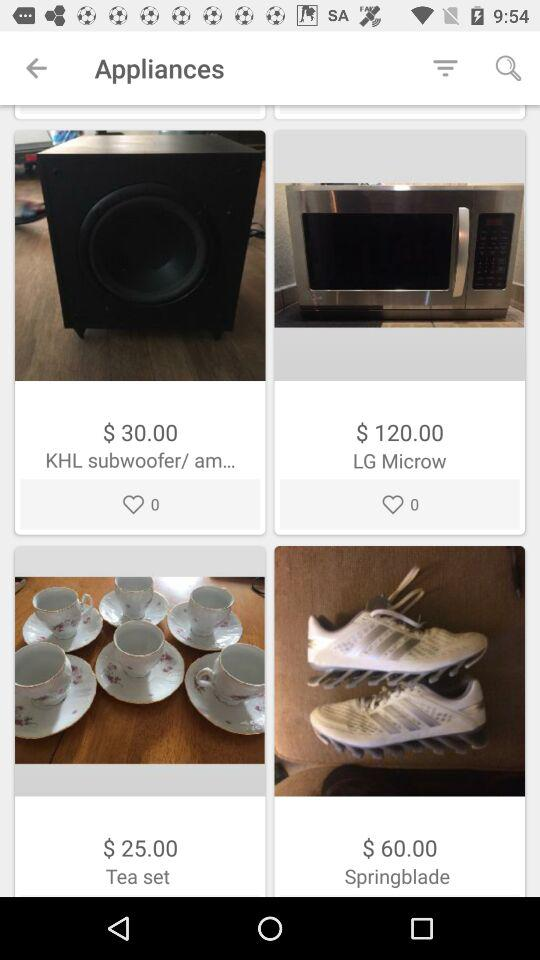How many likes are there of the LG Microw? There are 0 likes. 